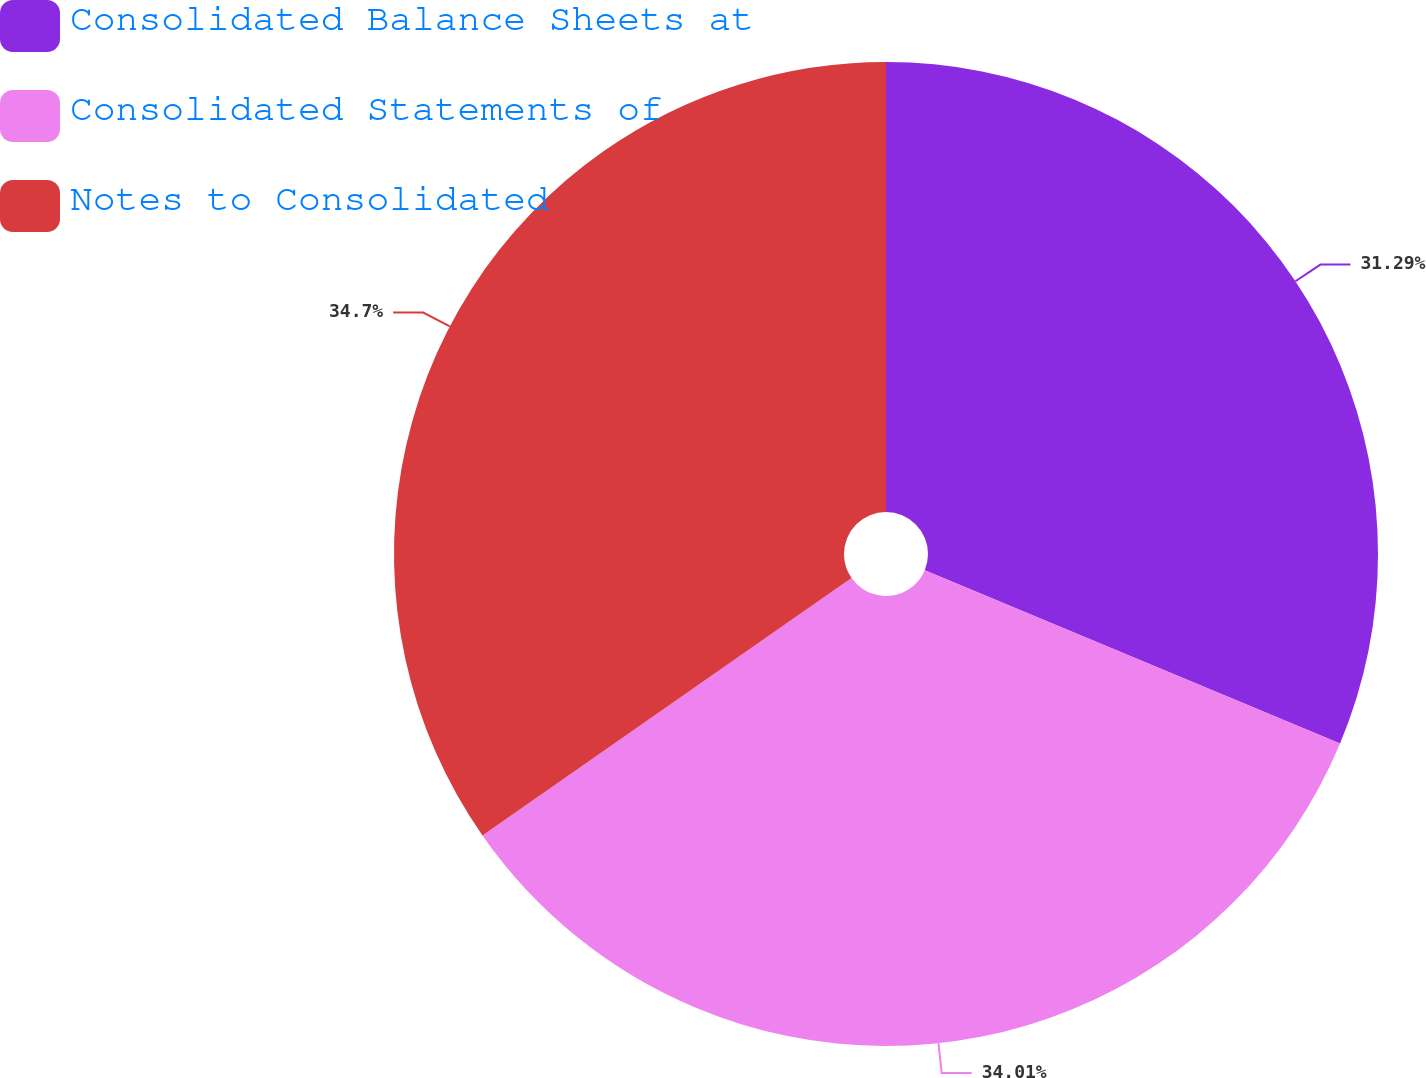<chart> <loc_0><loc_0><loc_500><loc_500><pie_chart><fcel>Consolidated Balance Sheets at<fcel>Consolidated Statements of<fcel>Notes to Consolidated<nl><fcel>31.29%<fcel>34.01%<fcel>34.69%<nl></chart> 